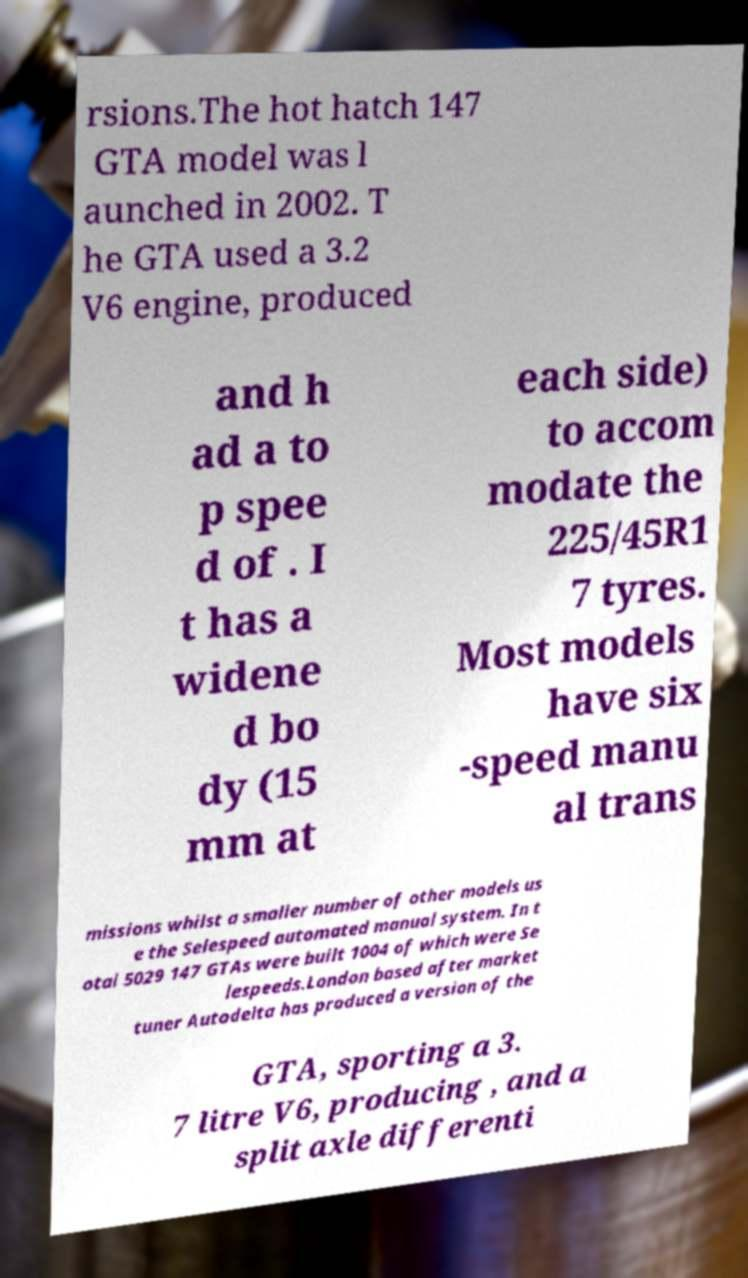Can you read and provide the text displayed in the image?This photo seems to have some interesting text. Can you extract and type it out for me? rsions.The hot hatch 147 GTA model was l aunched in 2002. T he GTA used a 3.2 V6 engine, produced and h ad a to p spee d of . I t has a widene d bo dy (15 mm at each side) to accom modate the 225/45R1 7 tyres. Most models have six -speed manu al trans missions whilst a smaller number of other models us e the Selespeed automated manual system. In t otal 5029 147 GTAs were built 1004 of which were Se lespeeds.London based after market tuner Autodelta has produced a version of the GTA, sporting a 3. 7 litre V6, producing , and a split axle differenti 